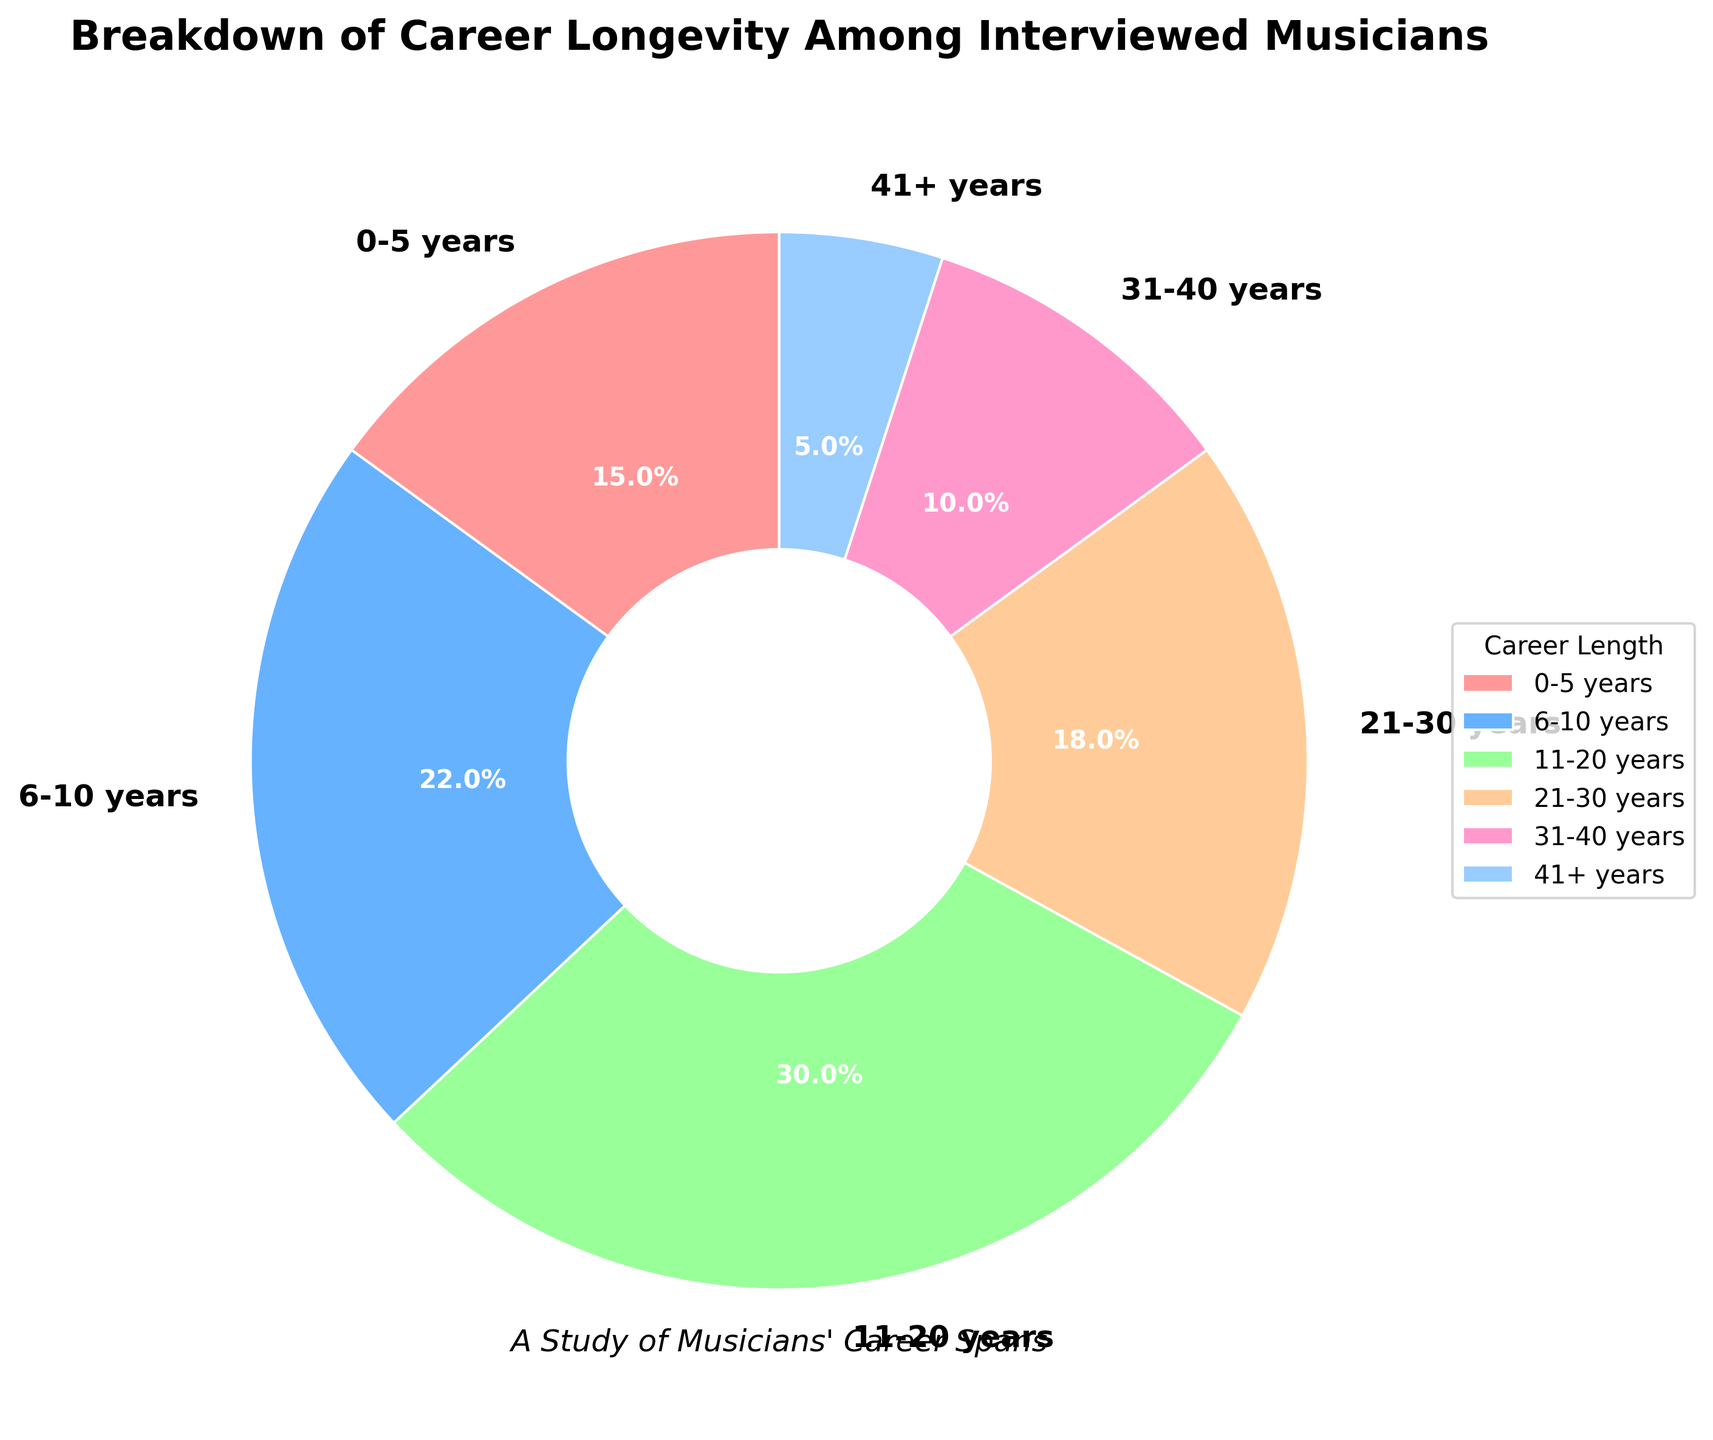What percentage of interviewed musicians have careers spanning 11-20 years? Locate the section labeled "11-20 years" on the pie chart. The percentage is indicated directly next to that label.
Answer: 30% Which career length category is the most common among the interviewed musicians? The largest segment in the pie chart represents the most common category. The "11-20 years" segment is the largest.
Answer: 11-20 years How much more common is a 6-10 year career compared to a 41+ year career? Subtract the percentage of the 41+ year category from the 6-10 year category (22% - 5% = 17%).
Answer: 17% more common Which category has fewer musicians: 21-30 years or 31-40 years? Compare the percentages of the two categories. The 31-40 years segment shows 10%, and the 21-30 years segment shows 18%.
Answer: 31-40 years What is the combined percentage of musicians with careers spanning 21-40 years? Add the percentages of both categories "21-30 years" and "31-40 years" (18% + 10% = 28%).
Answer: 28% How do the career lengths of 0-5 years and 41+ years compare in terms of percentage? Compare the two percentages directly from the pie chart: 0-5 years is 15% and 41+ years is 5%.
Answer: 0-5 years is 10% more common What percentage of the interviewed musicians have a career length of 10 years or less? Add the percentages of the categories "0-5 years" and "6-10 years" (15% + 22% = 37%).
Answer: 37% Which segment is represented by the pink color? Look for the color coding in the pie chart and identify the segment with the pink color.
Answer: 0-5 years What is the least common career longevity among the interviewed musicians? Identify the smallest segment in the pie chart. The "41+ years" segment is the smallest.
Answer: 41+ years If you combine all musicians with careers longer than 20 years, what is their total percentage? Add the percentages of "21-30 years," "31-40 years," and "41+ years" (18% + 10% + 5% = 33%).
Answer: 33% 